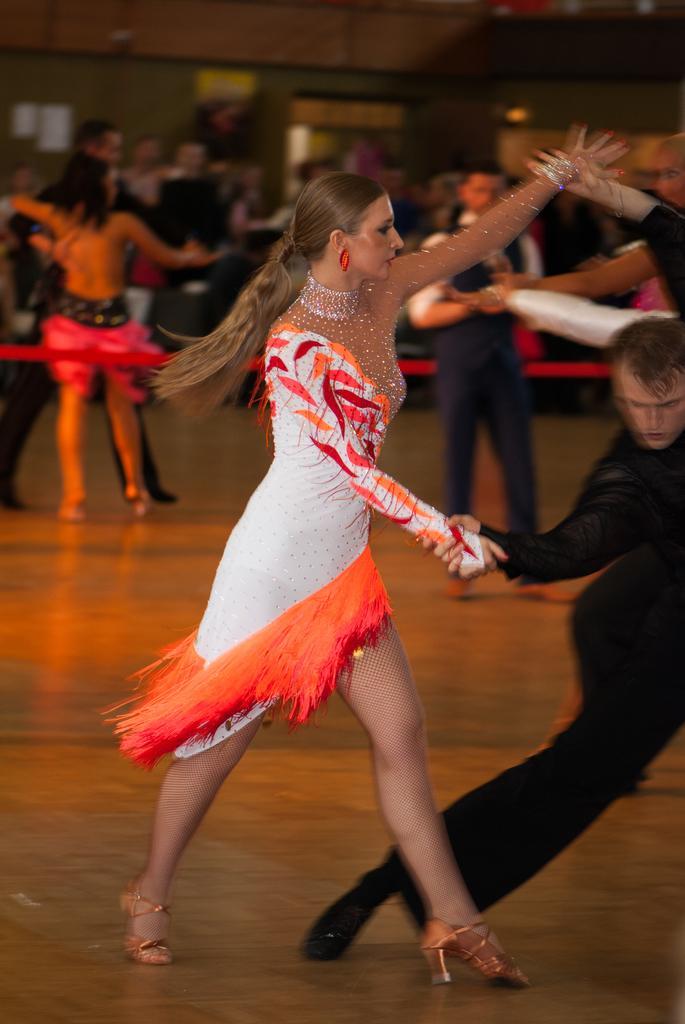Describe this image in one or two sentences. In this image we can see this woman wearing white dress and this man wearing black dress are standing on the wooden surface. The background of the image is slightly blurred, where we can see a few more people are standing on the ground and the wall. 